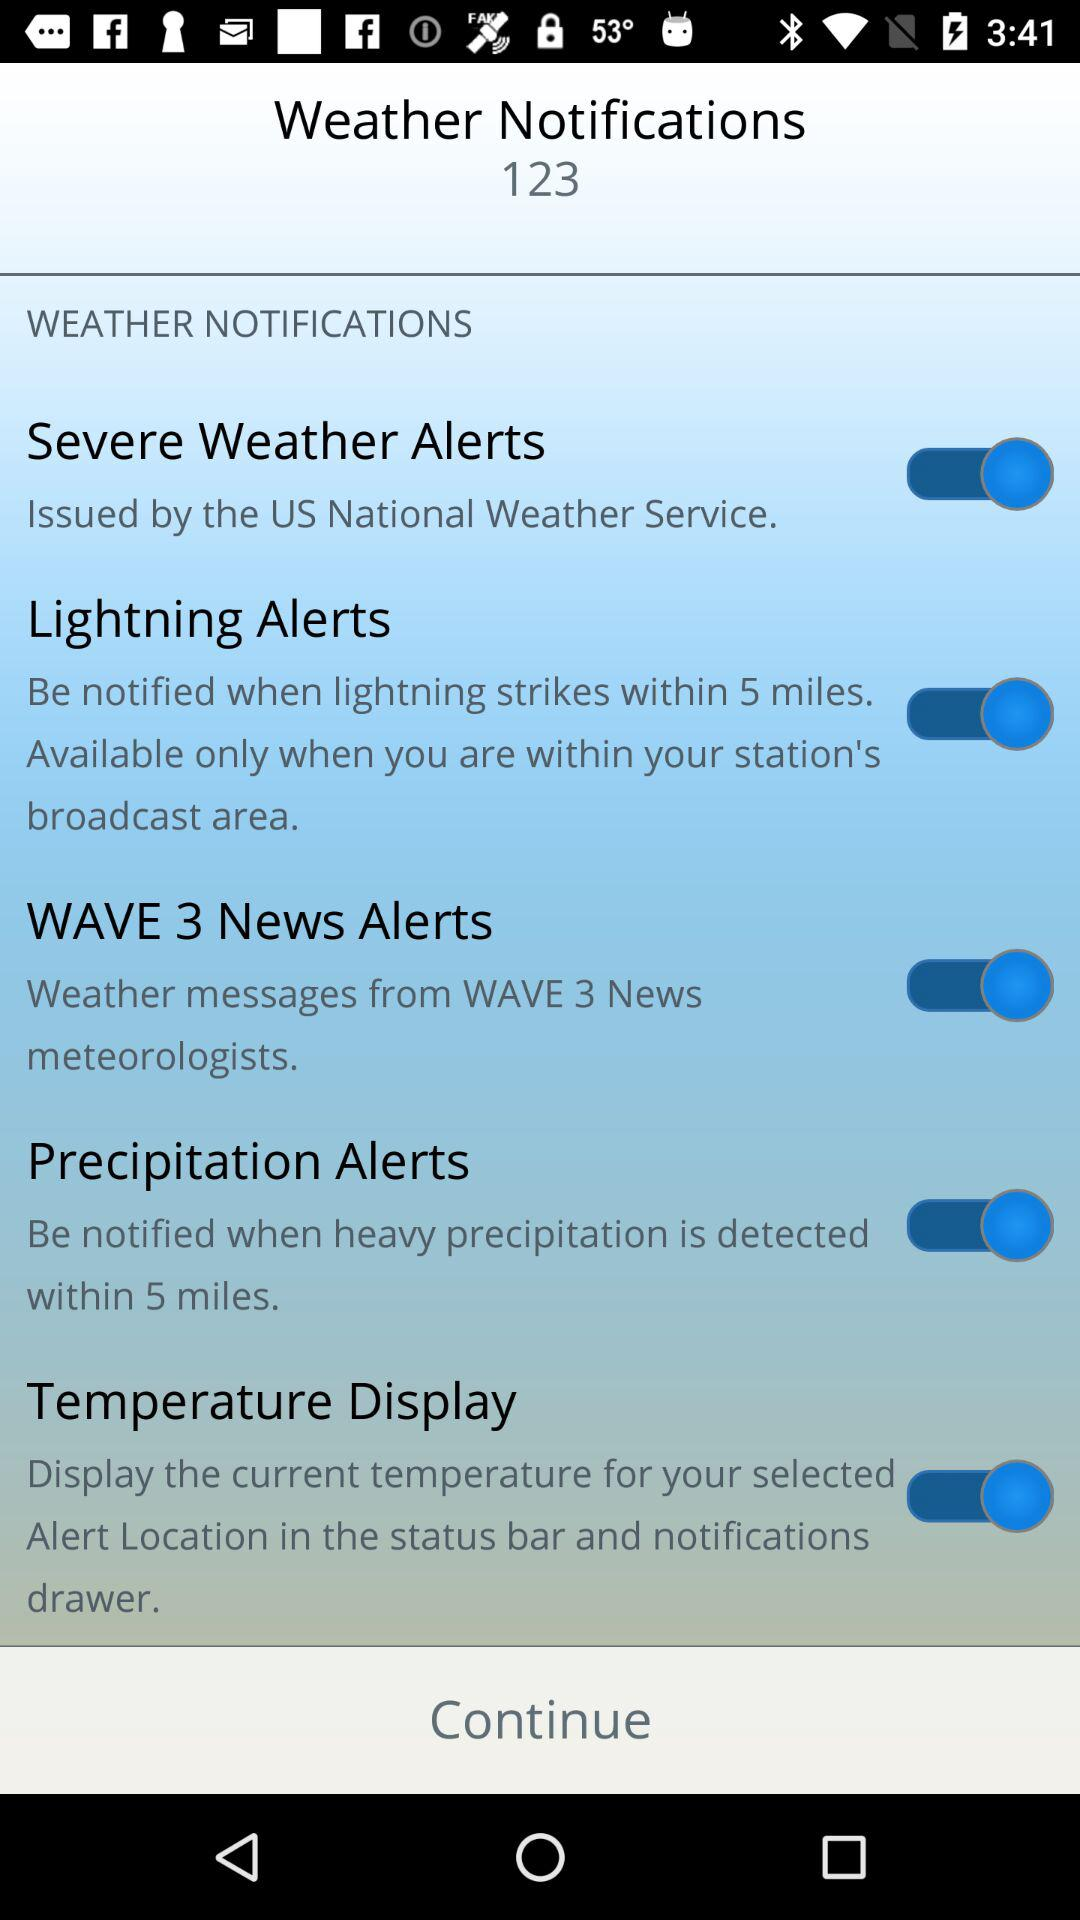How many alerts are there?
Answer the question using a single word or phrase. 5 